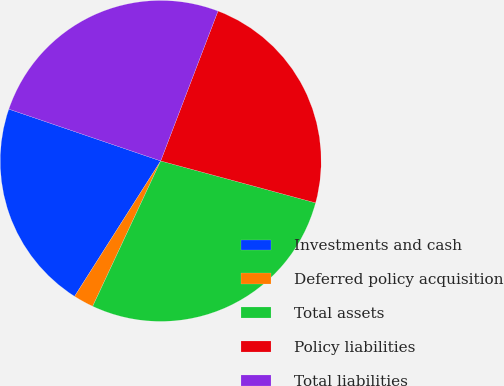Convert chart. <chart><loc_0><loc_0><loc_500><loc_500><pie_chart><fcel>Investments and cash<fcel>Deferred policy acquisition<fcel>Total assets<fcel>Policy liabilities<fcel>Total liabilities<nl><fcel>21.22%<fcel>2.05%<fcel>27.76%<fcel>23.4%<fcel>25.58%<nl></chart> 